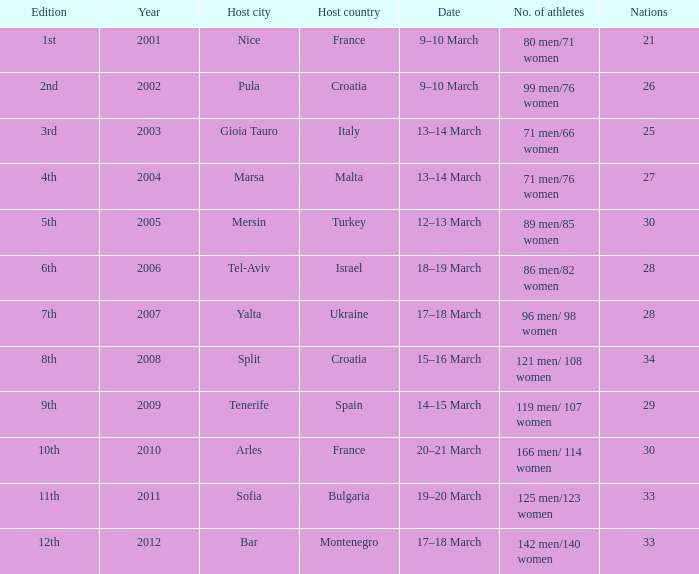Who was the host country when Bar was the host city? Montenegro. 